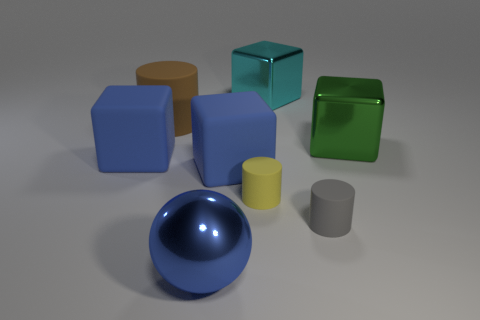What is the material of the large cylinder?
Offer a terse response. Rubber. How many other rubber things are the same shape as the large brown matte object?
Your response must be concise. 2. Are there any other things that are the same shape as the gray object?
Your answer should be compact. Yes. There is a big matte cube that is left of the big rubber cube that is right of the large blue object on the left side of the brown rubber object; what is its color?
Give a very brief answer. Blue. What number of small objects are shiny blocks or yellow objects?
Ensure brevity in your answer.  1. Is the number of blue rubber blocks that are to the right of the brown cylinder the same as the number of green objects?
Provide a succinct answer. Yes. Are there any tiny gray cylinders behind the big cyan metal block?
Provide a short and direct response. No. How many matte things are either balls or large brown objects?
Give a very brief answer. 1. How many blue blocks are on the left side of the big brown cylinder?
Make the answer very short. 1. Is there a metal sphere that has the same size as the cyan metal cube?
Provide a succinct answer. Yes. 